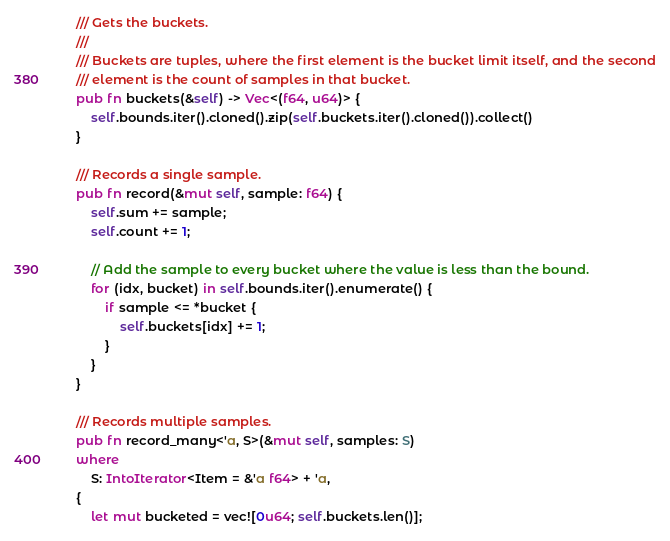<code> <loc_0><loc_0><loc_500><loc_500><_Rust_>    /// Gets the buckets.
    ///
    /// Buckets are tuples, where the first element is the bucket limit itself, and the second
    /// element is the count of samples in that bucket.
    pub fn buckets(&self) -> Vec<(f64, u64)> {
        self.bounds.iter().cloned().zip(self.buckets.iter().cloned()).collect()
    }

    /// Records a single sample.
    pub fn record(&mut self, sample: f64) {
        self.sum += sample;
        self.count += 1;

        // Add the sample to every bucket where the value is less than the bound.
        for (idx, bucket) in self.bounds.iter().enumerate() {
            if sample <= *bucket {
                self.buckets[idx] += 1;
            }
        }
    }

    /// Records multiple samples.
    pub fn record_many<'a, S>(&mut self, samples: S)
    where
        S: IntoIterator<Item = &'a f64> + 'a,
    {
        let mut bucketed = vec![0u64; self.buckets.len()];
</code> 